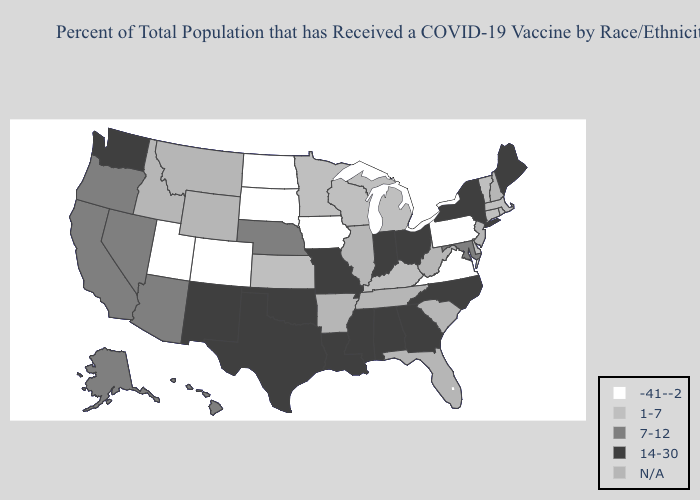Name the states that have a value in the range 7-12?
Concise answer only. Alaska, Arizona, California, Hawaii, Maryland, Nebraska, Nevada, Oregon. Does Delaware have the lowest value in the South?
Write a very short answer. No. Name the states that have a value in the range 1-7?
Write a very short answer. Connecticut, Delaware, Kansas, Kentucky, Massachusetts, Michigan, Minnesota, Rhode Island, Vermont, Wisconsin. What is the value of Missouri?
Answer briefly. 14-30. What is the value of Florida?
Be succinct. N/A. Name the states that have a value in the range 7-12?
Be succinct. Alaska, Arizona, California, Hawaii, Maryland, Nebraska, Nevada, Oregon. Among the states that border Massachusetts , which have the highest value?
Quick response, please. New York. What is the value of South Dakota?
Quick response, please. -41--2. What is the value of Florida?
Write a very short answer. N/A. Does California have the highest value in the West?
Concise answer only. No. What is the value of Delaware?
Answer briefly. 1-7. What is the value of Ohio?
Answer briefly. 14-30. Does Rhode Island have the highest value in the USA?
Concise answer only. No. What is the lowest value in states that border Montana?
Short answer required. -41--2. 